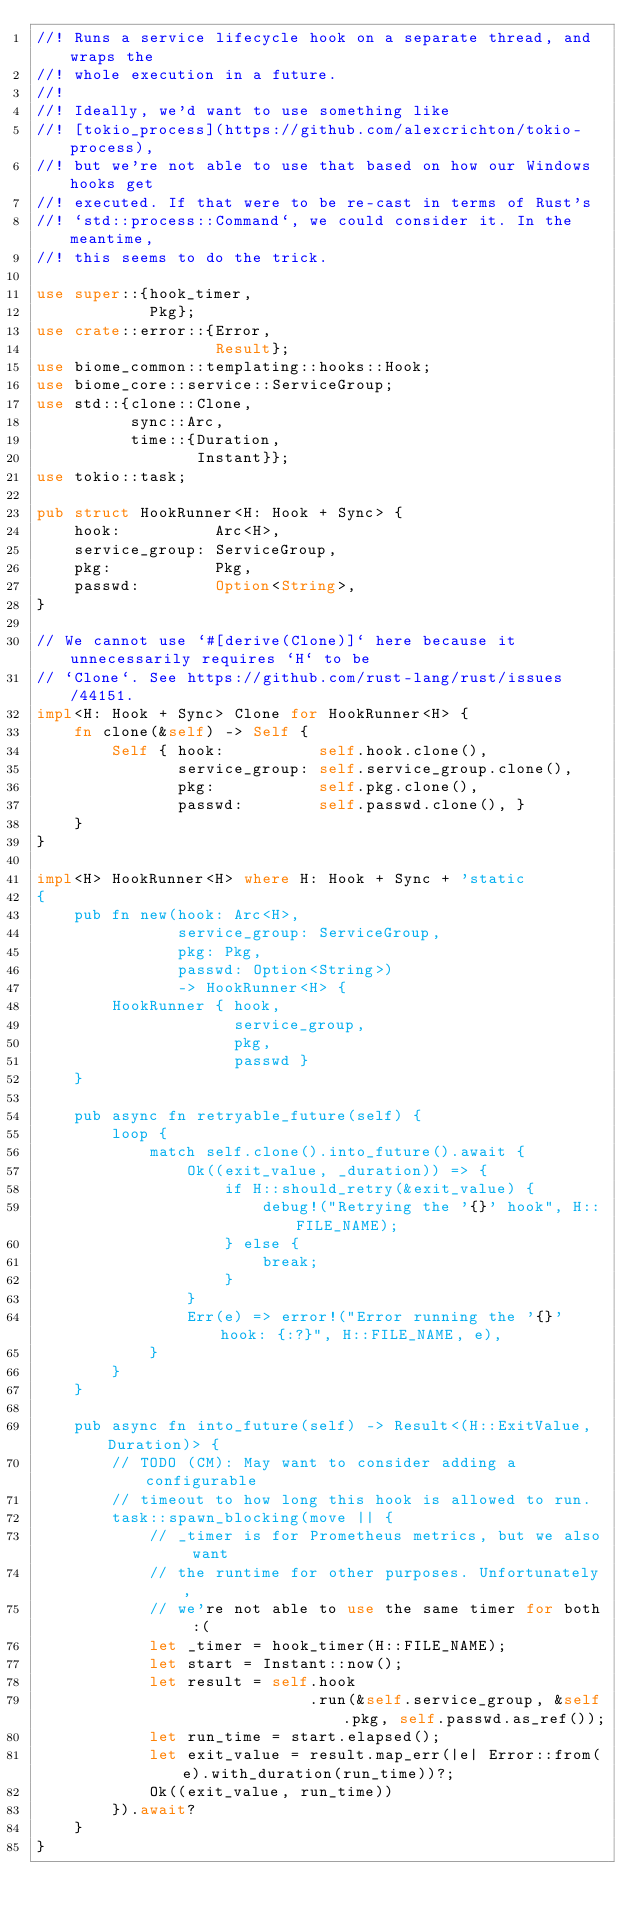Convert code to text. <code><loc_0><loc_0><loc_500><loc_500><_Rust_>//! Runs a service lifecycle hook on a separate thread, and wraps the
//! whole execution in a future.
//!
//! Ideally, we'd want to use something like
//! [tokio_process](https://github.com/alexcrichton/tokio-process),
//! but we're not able to use that based on how our Windows hooks get
//! executed. If that were to be re-cast in terms of Rust's
//! `std::process::Command`, we could consider it. In the meantime,
//! this seems to do the trick.

use super::{hook_timer,
            Pkg};
use crate::error::{Error,
                   Result};
use biome_common::templating::hooks::Hook;
use biome_core::service::ServiceGroup;
use std::{clone::Clone,
          sync::Arc,
          time::{Duration,
                 Instant}};
use tokio::task;

pub struct HookRunner<H: Hook + Sync> {
    hook:          Arc<H>,
    service_group: ServiceGroup,
    pkg:           Pkg,
    passwd:        Option<String>,
}

// We cannot use `#[derive(Clone)]` here because it unnecessarily requires `H` to be
// `Clone`. See https://github.com/rust-lang/rust/issues/44151.
impl<H: Hook + Sync> Clone for HookRunner<H> {
    fn clone(&self) -> Self {
        Self { hook:          self.hook.clone(),
               service_group: self.service_group.clone(),
               pkg:           self.pkg.clone(),
               passwd:        self.passwd.clone(), }
    }
}

impl<H> HookRunner<H> where H: Hook + Sync + 'static
{
    pub fn new(hook: Arc<H>,
               service_group: ServiceGroup,
               pkg: Pkg,
               passwd: Option<String>)
               -> HookRunner<H> {
        HookRunner { hook,
                     service_group,
                     pkg,
                     passwd }
    }

    pub async fn retryable_future(self) {
        loop {
            match self.clone().into_future().await {
                Ok((exit_value, _duration)) => {
                    if H::should_retry(&exit_value) {
                        debug!("Retrying the '{}' hook", H::FILE_NAME);
                    } else {
                        break;
                    }
                }
                Err(e) => error!("Error running the '{}' hook: {:?}", H::FILE_NAME, e),
            }
        }
    }

    pub async fn into_future(self) -> Result<(H::ExitValue, Duration)> {
        // TODO (CM): May want to consider adding a configurable
        // timeout to how long this hook is allowed to run.
        task::spawn_blocking(move || {
            // _timer is for Prometheus metrics, but we also want
            // the runtime for other purposes. Unfortunately,
            // we're not able to use the same timer for both :(
            let _timer = hook_timer(H::FILE_NAME);
            let start = Instant::now();
            let result = self.hook
                             .run(&self.service_group, &self.pkg, self.passwd.as_ref());
            let run_time = start.elapsed();
            let exit_value = result.map_err(|e| Error::from(e).with_duration(run_time))?;
            Ok((exit_value, run_time))
        }).await?
    }
}
</code> 